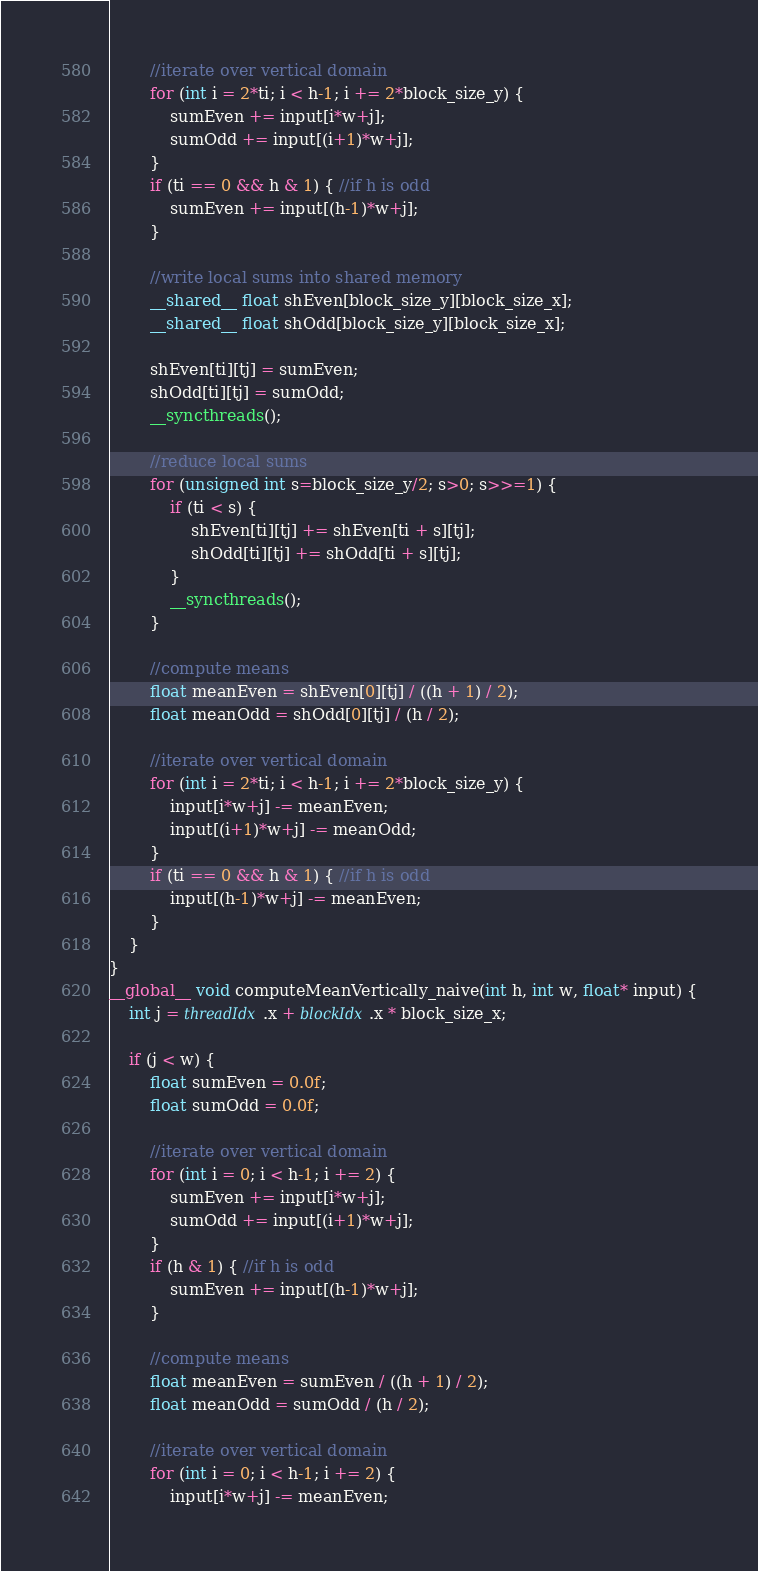Convert code to text. <code><loc_0><loc_0><loc_500><loc_500><_Cuda_>
        //iterate over vertical domain
        for (int i = 2*ti; i < h-1; i += 2*block_size_y) {
            sumEven += input[i*w+j];
            sumOdd += input[(i+1)*w+j];
        }
        if (ti == 0 && h & 1) { //if h is odd
            sumEven += input[(h-1)*w+j];
        }

        //write local sums into shared memory
        __shared__ float shEven[block_size_y][block_size_x];
        __shared__ float shOdd[block_size_y][block_size_x];

        shEven[ti][tj] = sumEven;
        shOdd[ti][tj] = sumOdd;
        __syncthreads();

        //reduce local sums
        for (unsigned int s=block_size_y/2; s>0; s>>=1) {
            if (ti < s) {
                shEven[ti][tj] += shEven[ti + s][tj];
                shOdd[ti][tj] += shOdd[ti + s][tj];
            }
            __syncthreads();
        }

        //compute means
        float meanEven = shEven[0][tj] / ((h + 1) / 2);
        float meanOdd = shOdd[0][tj] / (h / 2);

        //iterate over vertical domain
        for (int i = 2*ti; i < h-1; i += 2*block_size_y) {
            input[i*w+j] -= meanEven;
            input[(i+1)*w+j] -= meanOdd;
        }
        if (ti == 0 && h & 1) { //if h is odd
            input[(h-1)*w+j] -= meanEven;
        }
    }
}
__global__ void computeMeanVertically_naive(int h, int w, float* input) {
    int j = threadIdx.x + blockIdx.x * block_size_x;

    if (j < w) {
        float sumEven = 0.0f;
        float sumOdd = 0.0f;

        //iterate over vertical domain
        for (int i = 0; i < h-1; i += 2) {
            sumEven += input[i*w+j];
            sumOdd += input[(i+1)*w+j];
        }
        if (h & 1) { //if h is odd
            sumEven += input[(h-1)*w+j];
        }

        //compute means
        float meanEven = sumEven / ((h + 1) / 2);
        float meanOdd = sumOdd / (h / 2);

        //iterate over vertical domain
        for (int i = 0; i < h-1; i += 2) {
            input[i*w+j] -= meanEven;</code> 